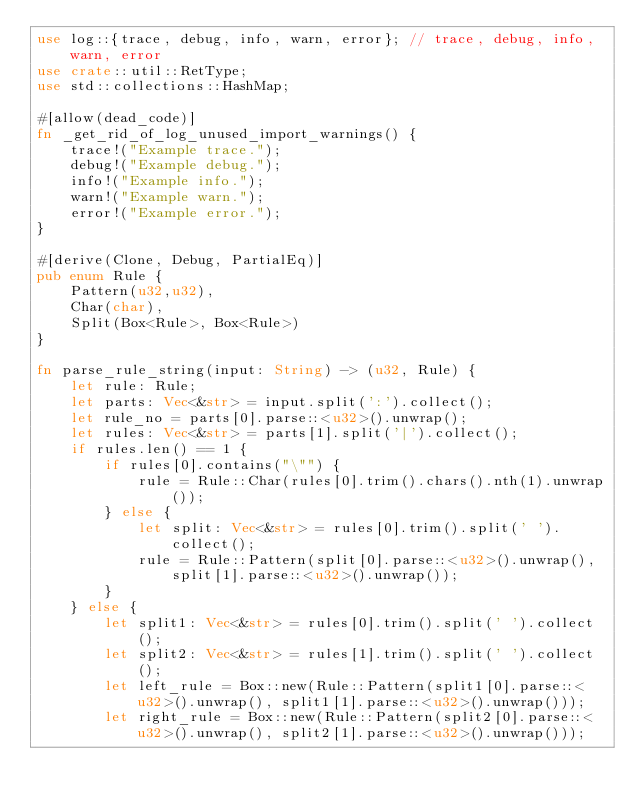<code> <loc_0><loc_0><loc_500><loc_500><_Rust_>use log::{trace, debug, info, warn, error}; // trace, debug, info, warn, error
use crate::util::RetType;
use std::collections::HashMap;

#[allow(dead_code)]
fn _get_rid_of_log_unused_import_warnings() {
    trace!("Example trace.");
    debug!("Example debug.");
    info!("Example info.");
    warn!("Example warn.");
    error!("Example error.");
}

#[derive(Clone, Debug, PartialEq)]
pub enum Rule {
    Pattern(u32,u32),
    Char(char),
    Split(Box<Rule>, Box<Rule>)
}

fn parse_rule_string(input: String) -> (u32, Rule) {
    let rule: Rule;
    let parts: Vec<&str> = input.split(':').collect();
    let rule_no = parts[0].parse::<u32>().unwrap();
    let rules: Vec<&str> = parts[1].split('|').collect();
    if rules.len() == 1 {
        if rules[0].contains("\"") {
            rule = Rule::Char(rules[0].trim().chars().nth(1).unwrap());
        } else {
            let split: Vec<&str> = rules[0].trim().split(' ').collect();
            rule = Rule::Pattern(split[0].parse::<u32>().unwrap(), split[1].parse::<u32>().unwrap());
        }
    } else {
        let split1: Vec<&str> = rules[0].trim().split(' ').collect();
        let split2: Vec<&str> = rules[1].trim().split(' ').collect();
        let left_rule = Box::new(Rule::Pattern(split1[0].parse::<u32>().unwrap(), split1[1].parse::<u32>().unwrap()));
        let right_rule = Box::new(Rule::Pattern(split2[0].parse::<u32>().unwrap(), split2[1].parse::<u32>().unwrap()));</code> 